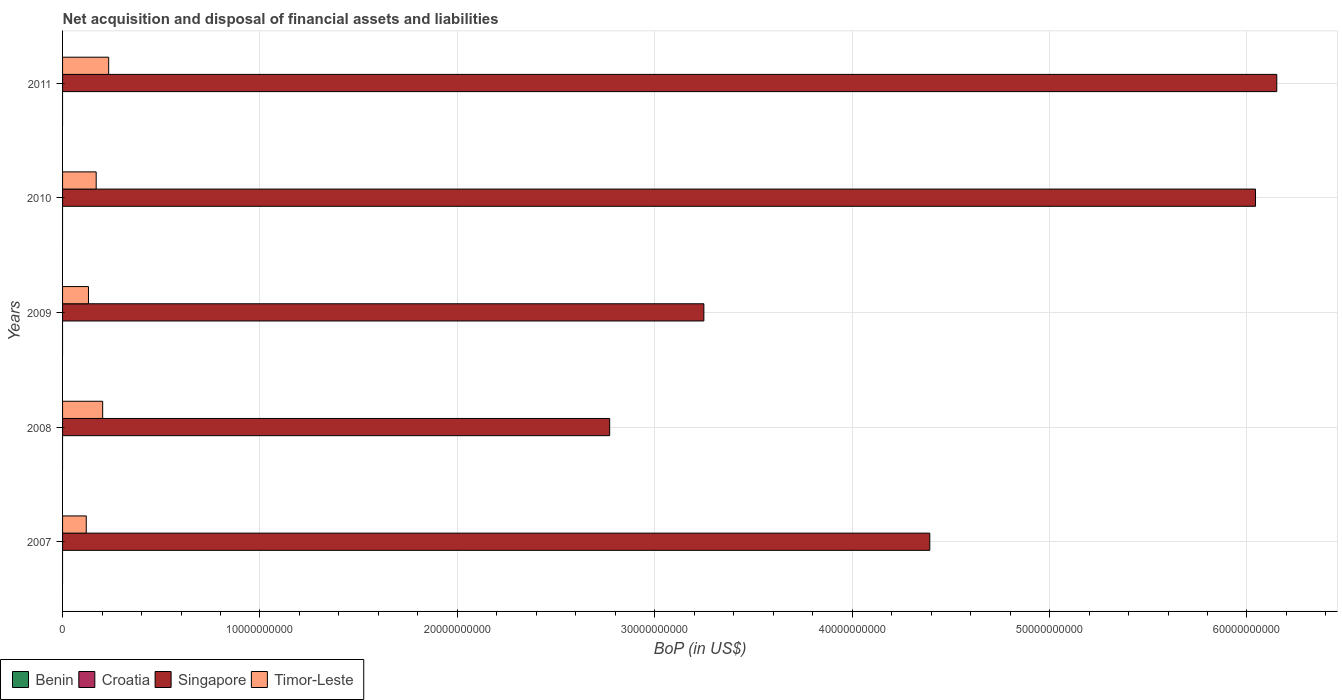How many groups of bars are there?
Your answer should be very brief. 5. Are the number of bars on each tick of the Y-axis equal?
Your answer should be very brief. Yes. How many bars are there on the 2nd tick from the bottom?
Your answer should be very brief. 2. What is the label of the 3rd group of bars from the top?
Make the answer very short. 2009. Across all years, what is the maximum Balance of Payments in Singapore?
Ensure brevity in your answer.  6.15e+1. Across all years, what is the minimum Balance of Payments in Croatia?
Provide a short and direct response. 0. What is the total Balance of Payments in Timor-Leste in the graph?
Keep it short and to the point. 8.58e+09. What is the difference between the Balance of Payments in Singapore in 2009 and that in 2010?
Your answer should be very brief. -2.79e+1. What is the average Balance of Payments in Croatia per year?
Your answer should be very brief. 0. In the year 2009, what is the difference between the Balance of Payments in Timor-Leste and Balance of Payments in Singapore?
Give a very brief answer. -3.12e+1. What is the ratio of the Balance of Payments in Timor-Leste in 2008 to that in 2009?
Provide a succinct answer. 1.55. What is the difference between the highest and the second highest Balance of Payments in Singapore?
Give a very brief answer. 1.08e+09. Is it the case that in every year, the sum of the Balance of Payments in Timor-Leste and Balance of Payments in Croatia is greater than the Balance of Payments in Benin?
Ensure brevity in your answer.  Yes. How many bars are there?
Your answer should be very brief. 10. What is the difference between two consecutive major ticks on the X-axis?
Offer a very short reply. 1.00e+1. Are the values on the major ticks of X-axis written in scientific E-notation?
Provide a short and direct response. No. Does the graph contain any zero values?
Keep it short and to the point. Yes. Where does the legend appear in the graph?
Provide a succinct answer. Bottom left. How are the legend labels stacked?
Provide a succinct answer. Horizontal. What is the title of the graph?
Offer a very short reply. Net acquisition and disposal of financial assets and liabilities. What is the label or title of the X-axis?
Your response must be concise. BoP (in US$). What is the BoP (in US$) in Benin in 2007?
Your response must be concise. 0. What is the BoP (in US$) in Singapore in 2007?
Provide a short and direct response. 4.39e+1. What is the BoP (in US$) of Timor-Leste in 2007?
Offer a terse response. 1.20e+09. What is the BoP (in US$) of Benin in 2008?
Your answer should be compact. 0. What is the BoP (in US$) in Croatia in 2008?
Ensure brevity in your answer.  0. What is the BoP (in US$) in Singapore in 2008?
Offer a very short reply. 2.77e+1. What is the BoP (in US$) in Timor-Leste in 2008?
Your response must be concise. 2.03e+09. What is the BoP (in US$) in Benin in 2009?
Your answer should be compact. 0. What is the BoP (in US$) in Croatia in 2009?
Offer a terse response. 0. What is the BoP (in US$) of Singapore in 2009?
Provide a short and direct response. 3.25e+1. What is the BoP (in US$) of Timor-Leste in 2009?
Give a very brief answer. 1.31e+09. What is the BoP (in US$) of Benin in 2010?
Ensure brevity in your answer.  0. What is the BoP (in US$) in Croatia in 2010?
Your answer should be compact. 0. What is the BoP (in US$) of Singapore in 2010?
Keep it short and to the point. 6.04e+1. What is the BoP (in US$) in Timor-Leste in 2010?
Provide a succinct answer. 1.70e+09. What is the BoP (in US$) of Singapore in 2011?
Offer a very short reply. 6.15e+1. What is the BoP (in US$) of Timor-Leste in 2011?
Your answer should be very brief. 2.34e+09. Across all years, what is the maximum BoP (in US$) in Singapore?
Provide a short and direct response. 6.15e+1. Across all years, what is the maximum BoP (in US$) of Timor-Leste?
Give a very brief answer. 2.34e+09. Across all years, what is the minimum BoP (in US$) of Singapore?
Provide a succinct answer. 2.77e+1. Across all years, what is the minimum BoP (in US$) in Timor-Leste?
Offer a very short reply. 1.20e+09. What is the total BoP (in US$) in Singapore in the graph?
Make the answer very short. 2.26e+11. What is the total BoP (in US$) of Timor-Leste in the graph?
Your answer should be very brief. 8.58e+09. What is the difference between the BoP (in US$) in Singapore in 2007 and that in 2008?
Keep it short and to the point. 1.62e+1. What is the difference between the BoP (in US$) in Timor-Leste in 2007 and that in 2008?
Offer a very short reply. -8.31e+08. What is the difference between the BoP (in US$) of Singapore in 2007 and that in 2009?
Offer a terse response. 1.14e+1. What is the difference between the BoP (in US$) of Timor-Leste in 2007 and that in 2009?
Keep it short and to the point. -1.12e+08. What is the difference between the BoP (in US$) of Singapore in 2007 and that in 2010?
Give a very brief answer. -1.65e+1. What is the difference between the BoP (in US$) in Timor-Leste in 2007 and that in 2010?
Give a very brief answer. -5.03e+08. What is the difference between the BoP (in US$) in Singapore in 2007 and that in 2011?
Make the answer very short. -1.76e+1. What is the difference between the BoP (in US$) of Timor-Leste in 2007 and that in 2011?
Keep it short and to the point. -1.13e+09. What is the difference between the BoP (in US$) of Singapore in 2008 and that in 2009?
Offer a very short reply. -4.77e+09. What is the difference between the BoP (in US$) of Timor-Leste in 2008 and that in 2009?
Your answer should be very brief. 7.20e+08. What is the difference between the BoP (in US$) in Singapore in 2008 and that in 2010?
Make the answer very short. -3.27e+1. What is the difference between the BoP (in US$) of Timor-Leste in 2008 and that in 2010?
Offer a terse response. 3.29e+08. What is the difference between the BoP (in US$) in Singapore in 2008 and that in 2011?
Provide a succinct answer. -3.38e+1. What is the difference between the BoP (in US$) of Timor-Leste in 2008 and that in 2011?
Provide a succinct answer. -3.04e+08. What is the difference between the BoP (in US$) of Singapore in 2009 and that in 2010?
Your response must be concise. -2.79e+1. What is the difference between the BoP (in US$) in Timor-Leste in 2009 and that in 2010?
Provide a succinct answer. -3.91e+08. What is the difference between the BoP (in US$) of Singapore in 2009 and that in 2011?
Your answer should be compact. -2.90e+1. What is the difference between the BoP (in US$) in Timor-Leste in 2009 and that in 2011?
Offer a very short reply. -1.02e+09. What is the difference between the BoP (in US$) of Singapore in 2010 and that in 2011?
Your answer should be compact. -1.08e+09. What is the difference between the BoP (in US$) of Timor-Leste in 2010 and that in 2011?
Ensure brevity in your answer.  -6.32e+08. What is the difference between the BoP (in US$) of Singapore in 2007 and the BoP (in US$) of Timor-Leste in 2008?
Offer a terse response. 4.19e+1. What is the difference between the BoP (in US$) of Singapore in 2007 and the BoP (in US$) of Timor-Leste in 2009?
Give a very brief answer. 4.26e+1. What is the difference between the BoP (in US$) of Singapore in 2007 and the BoP (in US$) of Timor-Leste in 2010?
Your answer should be very brief. 4.22e+1. What is the difference between the BoP (in US$) of Singapore in 2007 and the BoP (in US$) of Timor-Leste in 2011?
Ensure brevity in your answer.  4.16e+1. What is the difference between the BoP (in US$) of Singapore in 2008 and the BoP (in US$) of Timor-Leste in 2009?
Offer a terse response. 2.64e+1. What is the difference between the BoP (in US$) in Singapore in 2008 and the BoP (in US$) in Timor-Leste in 2010?
Keep it short and to the point. 2.60e+1. What is the difference between the BoP (in US$) in Singapore in 2008 and the BoP (in US$) in Timor-Leste in 2011?
Your answer should be compact. 2.54e+1. What is the difference between the BoP (in US$) in Singapore in 2009 and the BoP (in US$) in Timor-Leste in 2010?
Your answer should be compact. 3.08e+1. What is the difference between the BoP (in US$) of Singapore in 2009 and the BoP (in US$) of Timor-Leste in 2011?
Ensure brevity in your answer.  3.02e+1. What is the difference between the BoP (in US$) of Singapore in 2010 and the BoP (in US$) of Timor-Leste in 2011?
Keep it short and to the point. 5.81e+1. What is the average BoP (in US$) in Croatia per year?
Your answer should be very brief. 0. What is the average BoP (in US$) in Singapore per year?
Give a very brief answer. 4.52e+1. What is the average BoP (in US$) in Timor-Leste per year?
Offer a very short reply. 1.72e+09. In the year 2007, what is the difference between the BoP (in US$) of Singapore and BoP (in US$) of Timor-Leste?
Keep it short and to the point. 4.27e+1. In the year 2008, what is the difference between the BoP (in US$) of Singapore and BoP (in US$) of Timor-Leste?
Offer a terse response. 2.57e+1. In the year 2009, what is the difference between the BoP (in US$) of Singapore and BoP (in US$) of Timor-Leste?
Provide a short and direct response. 3.12e+1. In the year 2010, what is the difference between the BoP (in US$) in Singapore and BoP (in US$) in Timor-Leste?
Ensure brevity in your answer.  5.87e+1. In the year 2011, what is the difference between the BoP (in US$) of Singapore and BoP (in US$) of Timor-Leste?
Your answer should be very brief. 5.92e+1. What is the ratio of the BoP (in US$) of Singapore in 2007 to that in 2008?
Give a very brief answer. 1.59. What is the ratio of the BoP (in US$) of Timor-Leste in 2007 to that in 2008?
Provide a succinct answer. 0.59. What is the ratio of the BoP (in US$) of Singapore in 2007 to that in 2009?
Provide a short and direct response. 1.35. What is the ratio of the BoP (in US$) of Timor-Leste in 2007 to that in 2009?
Ensure brevity in your answer.  0.91. What is the ratio of the BoP (in US$) in Singapore in 2007 to that in 2010?
Offer a very short reply. 0.73. What is the ratio of the BoP (in US$) in Timor-Leste in 2007 to that in 2010?
Make the answer very short. 0.7. What is the ratio of the BoP (in US$) of Singapore in 2007 to that in 2011?
Offer a terse response. 0.71. What is the ratio of the BoP (in US$) of Timor-Leste in 2007 to that in 2011?
Provide a succinct answer. 0.51. What is the ratio of the BoP (in US$) of Singapore in 2008 to that in 2009?
Keep it short and to the point. 0.85. What is the ratio of the BoP (in US$) in Timor-Leste in 2008 to that in 2009?
Offer a terse response. 1.55. What is the ratio of the BoP (in US$) of Singapore in 2008 to that in 2010?
Your answer should be very brief. 0.46. What is the ratio of the BoP (in US$) in Timor-Leste in 2008 to that in 2010?
Your answer should be compact. 1.19. What is the ratio of the BoP (in US$) of Singapore in 2008 to that in 2011?
Offer a terse response. 0.45. What is the ratio of the BoP (in US$) of Timor-Leste in 2008 to that in 2011?
Your answer should be very brief. 0.87. What is the ratio of the BoP (in US$) of Singapore in 2009 to that in 2010?
Your answer should be very brief. 0.54. What is the ratio of the BoP (in US$) in Timor-Leste in 2009 to that in 2010?
Your answer should be compact. 0.77. What is the ratio of the BoP (in US$) of Singapore in 2009 to that in 2011?
Provide a short and direct response. 0.53. What is the ratio of the BoP (in US$) of Timor-Leste in 2009 to that in 2011?
Your answer should be very brief. 0.56. What is the ratio of the BoP (in US$) in Singapore in 2010 to that in 2011?
Provide a short and direct response. 0.98. What is the ratio of the BoP (in US$) in Timor-Leste in 2010 to that in 2011?
Ensure brevity in your answer.  0.73. What is the difference between the highest and the second highest BoP (in US$) in Singapore?
Provide a succinct answer. 1.08e+09. What is the difference between the highest and the second highest BoP (in US$) of Timor-Leste?
Your answer should be compact. 3.04e+08. What is the difference between the highest and the lowest BoP (in US$) in Singapore?
Offer a terse response. 3.38e+1. What is the difference between the highest and the lowest BoP (in US$) in Timor-Leste?
Make the answer very short. 1.13e+09. 